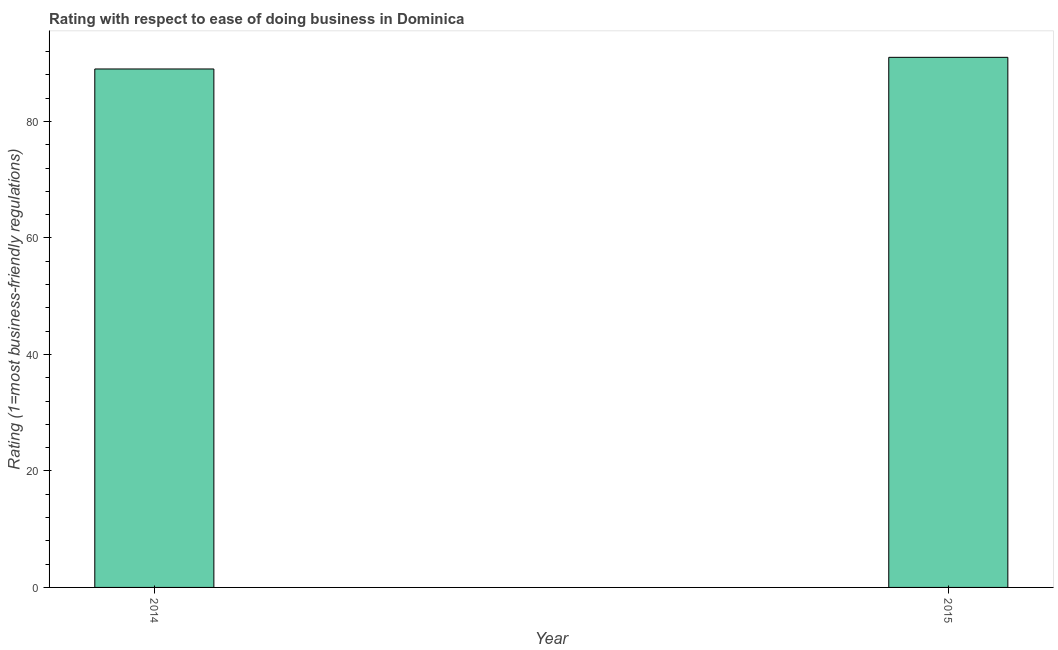Does the graph contain grids?
Provide a succinct answer. No. What is the title of the graph?
Keep it short and to the point. Rating with respect to ease of doing business in Dominica. What is the label or title of the Y-axis?
Make the answer very short. Rating (1=most business-friendly regulations). What is the ease of doing business index in 2014?
Keep it short and to the point. 89. Across all years, what is the maximum ease of doing business index?
Your answer should be very brief. 91. Across all years, what is the minimum ease of doing business index?
Keep it short and to the point. 89. In which year was the ease of doing business index maximum?
Provide a short and direct response. 2015. In which year was the ease of doing business index minimum?
Keep it short and to the point. 2014. What is the sum of the ease of doing business index?
Provide a succinct answer. 180. What is the difference between the ease of doing business index in 2014 and 2015?
Give a very brief answer. -2. What is the average ease of doing business index per year?
Offer a terse response. 90. What is the median ease of doing business index?
Provide a succinct answer. 90. In how many years, is the ease of doing business index greater than 48 ?
Keep it short and to the point. 2. What is the ratio of the ease of doing business index in 2014 to that in 2015?
Make the answer very short. 0.98. In how many years, is the ease of doing business index greater than the average ease of doing business index taken over all years?
Offer a terse response. 1. How many years are there in the graph?
Make the answer very short. 2. What is the difference between two consecutive major ticks on the Y-axis?
Keep it short and to the point. 20. What is the Rating (1=most business-friendly regulations) in 2014?
Your response must be concise. 89. What is the Rating (1=most business-friendly regulations) in 2015?
Your response must be concise. 91. What is the difference between the Rating (1=most business-friendly regulations) in 2014 and 2015?
Give a very brief answer. -2. 